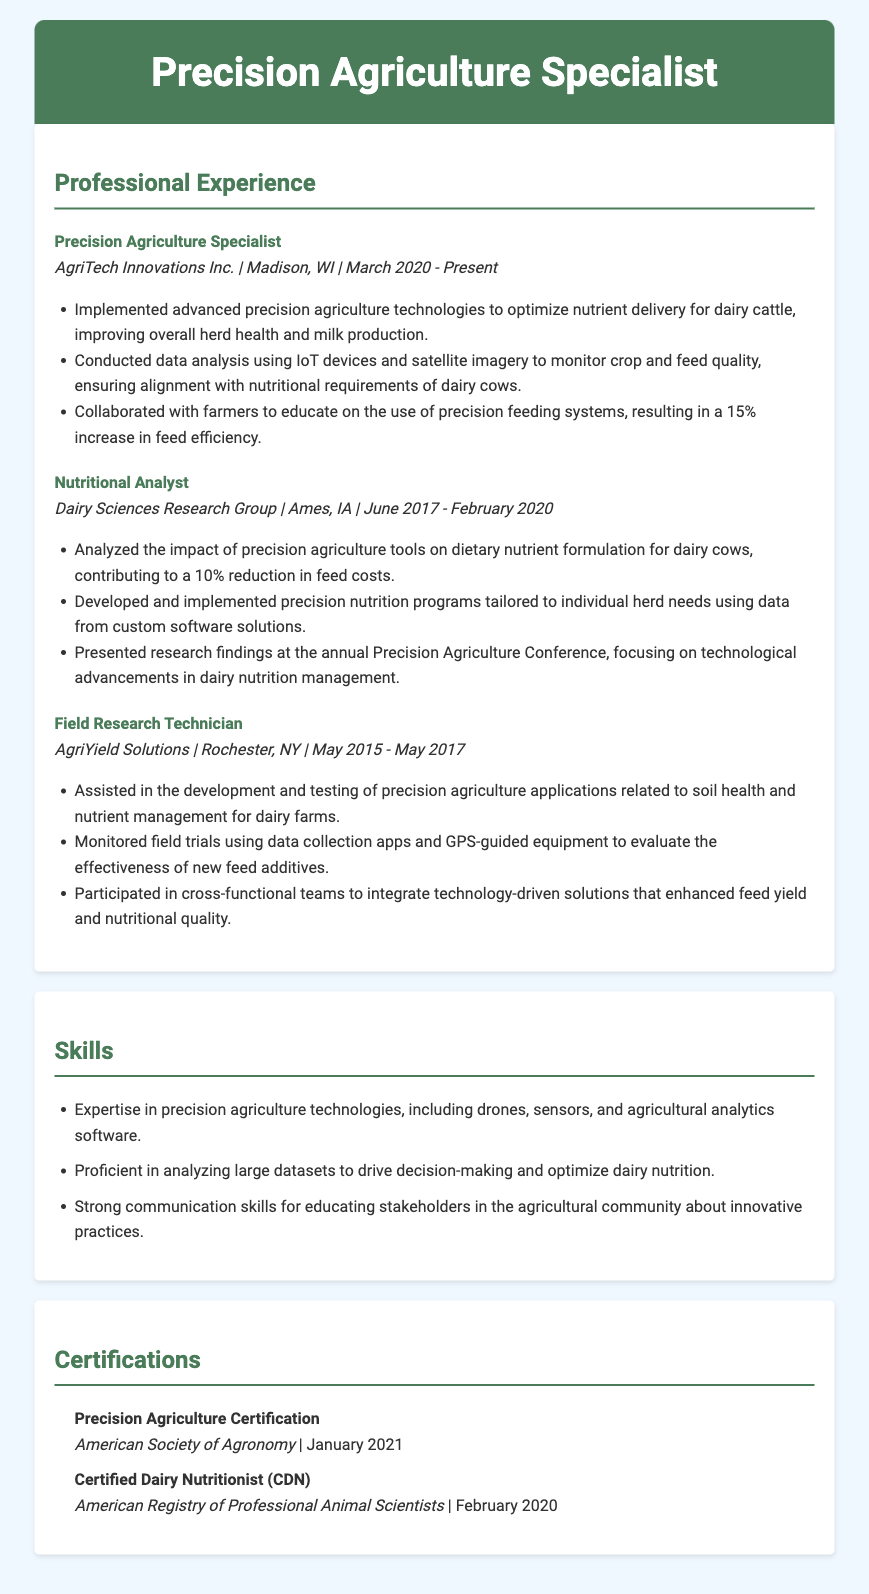what is the job title at AgriTech Innovations Inc.? The job title listed under AgriTech Innovations Inc. is Precision Agriculture Specialist.
Answer: Precision Agriculture Specialist what was the duration of the role at Dairy Sciences Research Group? The duration listed for the Nutritional Analyst role is from June 2017 to February 2020.
Answer: June 2017 - February 2020 what percentage increase in feed efficiency was achieved? The resume states a 15% increase in feed efficiency due to collaboration and education on precision feeding systems.
Answer: 15% how many certifications are listed in the document? There are two certifications mentioned in the certifications section.
Answer: 2 which organization provided the Precision Agriculture Certification? The certification was awarded by the American Society of Agronomy.
Answer: American Society of Agronomy what was the focus of the presentation at the Precision Agriculture Conference? The presentation focused on technological advancements in dairy nutrition management.
Answer: Technological advancements in dairy nutrition management what role involved monitoring field trials? The role that involved monitoring field trials was Field Research Technician.
Answer: Field Research Technician what type of technologies is the specialist an expert in? The document states expertise in precision agriculture technologies, including drones, sensors, and agricultural analytics software.
Answer: Drones, sensors, and agricultural analytics software 